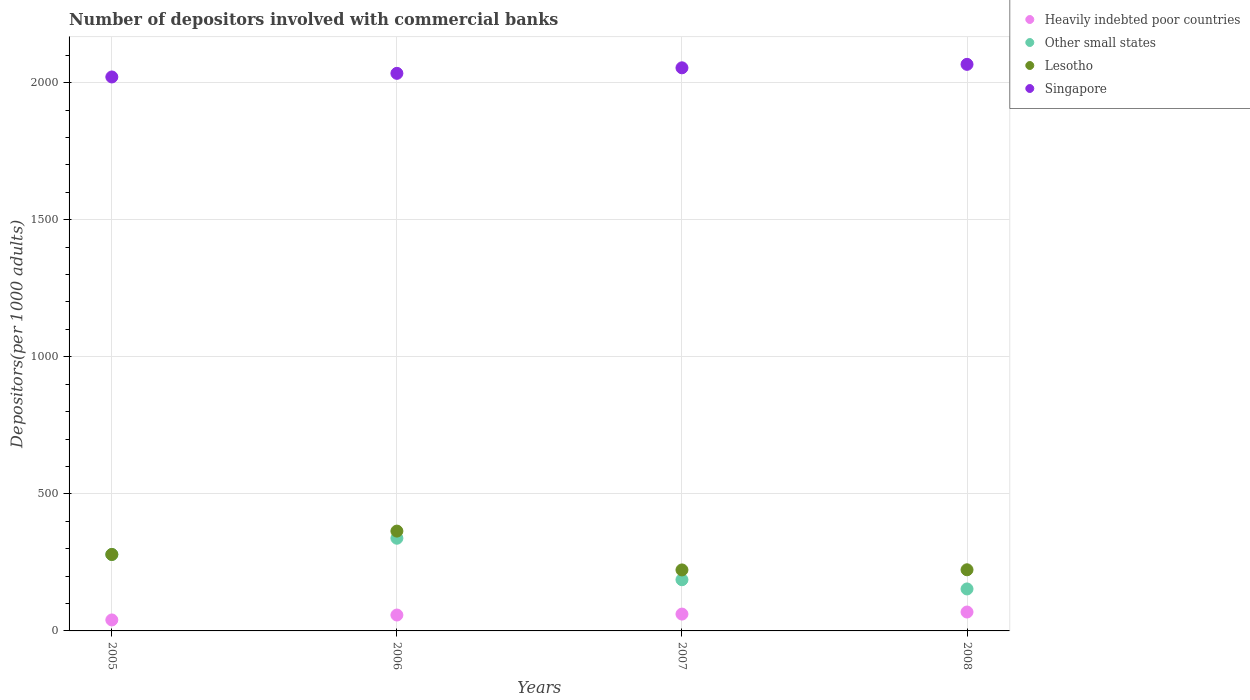What is the number of depositors involved with commercial banks in Other small states in 2005?
Keep it short and to the point. 278.86. Across all years, what is the maximum number of depositors involved with commercial banks in Other small states?
Provide a short and direct response. 338.08. Across all years, what is the minimum number of depositors involved with commercial banks in Singapore?
Offer a very short reply. 2020.56. In which year was the number of depositors involved with commercial banks in Other small states maximum?
Offer a terse response. 2006. What is the total number of depositors involved with commercial banks in Lesotho in the graph?
Your answer should be compact. 1088.47. What is the difference between the number of depositors involved with commercial banks in Heavily indebted poor countries in 2007 and that in 2008?
Offer a terse response. -7.53. What is the difference between the number of depositors involved with commercial banks in Other small states in 2008 and the number of depositors involved with commercial banks in Singapore in 2007?
Your response must be concise. -1900.84. What is the average number of depositors involved with commercial banks in Heavily indebted poor countries per year?
Keep it short and to the point. 57.09. In the year 2007, what is the difference between the number of depositors involved with commercial banks in Heavily indebted poor countries and number of depositors involved with commercial banks in Singapore?
Offer a very short reply. -1992.54. In how many years, is the number of depositors involved with commercial banks in Other small states greater than 1600?
Give a very brief answer. 0. What is the ratio of the number of depositors involved with commercial banks in Heavily indebted poor countries in 2006 to that in 2008?
Offer a very short reply. 0.84. What is the difference between the highest and the second highest number of depositors involved with commercial banks in Lesotho?
Give a very brief answer. 85.25. What is the difference between the highest and the lowest number of depositors involved with commercial banks in Heavily indebted poor countries?
Make the answer very short. 28.9. Is the sum of the number of depositors involved with commercial banks in Lesotho in 2007 and 2008 greater than the maximum number of depositors involved with commercial banks in Singapore across all years?
Provide a short and direct response. No. Does the number of depositors involved with commercial banks in Heavily indebted poor countries monotonically increase over the years?
Make the answer very short. Yes. Is the number of depositors involved with commercial banks in Singapore strictly less than the number of depositors involved with commercial banks in Other small states over the years?
Make the answer very short. No. How many dotlines are there?
Your response must be concise. 4. How many years are there in the graph?
Your response must be concise. 4. Are the values on the major ticks of Y-axis written in scientific E-notation?
Offer a very short reply. No. Does the graph contain grids?
Give a very brief answer. Yes. Where does the legend appear in the graph?
Make the answer very short. Top right. How many legend labels are there?
Provide a short and direct response. 4. What is the title of the graph?
Make the answer very short. Number of depositors involved with commercial banks. What is the label or title of the Y-axis?
Your answer should be compact. Depositors(per 1000 adults). What is the Depositors(per 1000 adults) in Heavily indebted poor countries in 2005?
Offer a very short reply. 40.04. What is the Depositors(per 1000 adults) in Other small states in 2005?
Your answer should be very brief. 278.86. What is the Depositors(per 1000 adults) of Lesotho in 2005?
Provide a succinct answer. 278.86. What is the Depositors(per 1000 adults) in Singapore in 2005?
Keep it short and to the point. 2020.56. What is the Depositors(per 1000 adults) of Heavily indebted poor countries in 2006?
Your answer should be very brief. 57.99. What is the Depositors(per 1000 adults) in Other small states in 2006?
Provide a short and direct response. 338.08. What is the Depositors(per 1000 adults) of Lesotho in 2006?
Offer a terse response. 364.12. What is the Depositors(per 1000 adults) in Singapore in 2006?
Provide a short and direct response. 2033.78. What is the Depositors(per 1000 adults) in Heavily indebted poor countries in 2007?
Your answer should be very brief. 61.41. What is the Depositors(per 1000 adults) in Other small states in 2007?
Make the answer very short. 186.74. What is the Depositors(per 1000 adults) of Lesotho in 2007?
Make the answer very short. 222.49. What is the Depositors(per 1000 adults) of Singapore in 2007?
Offer a terse response. 2053.95. What is the Depositors(per 1000 adults) in Heavily indebted poor countries in 2008?
Keep it short and to the point. 68.94. What is the Depositors(per 1000 adults) in Other small states in 2008?
Your answer should be compact. 153.11. What is the Depositors(per 1000 adults) in Lesotho in 2008?
Your response must be concise. 223. What is the Depositors(per 1000 adults) in Singapore in 2008?
Provide a succinct answer. 2066.57. Across all years, what is the maximum Depositors(per 1000 adults) in Heavily indebted poor countries?
Keep it short and to the point. 68.94. Across all years, what is the maximum Depositors(per 1000 adults) in Other small states?
Offer a very short reply. 338.08. Across all years, what is the maximum Depositors(per 1000 adults) of Lesotho?
Give a very brief answer. 364.12. Across all years, what is the maximum Depositors(per 1000 adults) in Singapore?
Keep it short and to the point. 2066.57. Across all years, what is the minimum Depositors(per 1000 adults) in Heavily indebted poor countries?
Your response must be concise. 40.04. Across all years, what is the minimum Depositors(per 1000 adults) of Other small states?
Offer a terse response. 153.11. Across all years, what is the minimum Depositors(per 1000 adults) of Lesotho?
Your response must be concise. 222.49. Across all years, what is the minimum Depositors(per 1000 adults) in Singapore?
Give a very brief answer. 2020.56. What is the total Depositors(per 1000 adults) of Heavily indebted poor countries in the graph?
Your answer should be compact. 228.38. What is the total Depositors(per 1000 adults) of Other small states in the graph?
Provide a short and direct response. 956.79. What is the total Depositors(per 1000 adults) of Lesotho in the graph?
Offer a terse response. 1088.47. What is the total Depositors(per 1000 adults) in Singapore in the graph?
Your answer should be compact. 8174.86. What is the difference between the Depositors(per 1000 adults) in Heavily indebted poor countries in 2005 and that in 2006?
Make the answer very short. -17.95. What is the difference between the Depositors(per 1000 adults) in Other small states in 2005 and that in 2006?
Make the answer very short. -59.21. What is the difference between the Depositors(per 1000 adults) in Lesotho in 2005 and that in 2006?
Make the answer very short. -85.25. What is the difference between the Depositors(per 1000 adults) in Singapore in 2005 and that in 2006?
Your response must be concise. -13.21. What is the difference between the Depositors(per 1000 adults) in Heavily indebted poor countries in 2005 and that in 2007?
Provide a succinct answer. -21.37. What is the difference between the Depositors(per 1000 adults) of Other small states in 2005 and that in 2007?
Offer a very short reply. 92.12. What is the difference between the Depositors(per 1000 adults) in Lesotho in 2005 and that in 2007?
Your answer should be very brief. 56.37. What is the difference between the Depositors(per 1000 adults) of Singapore in 2005 and that in 2007?
Your response must be concise. -33.38. What is the difference between the Depositors(per 1000 adults) in Heavily indebted poor countries in 2005 and that in 2008?
Provide a short and direct response. -28.9. What is the difference between the Depositors(per 1000 adults) in Other small states in 2005 and that in 2008?
Make the answer very short. 125.76. What is the difference between the Depositors(per 1000 adults) of Lesotho in 2005 and that in 2008?
Your answer should be compact. 55.86. What is the difference between the Depositors(per 1000 adults) in Singapore in 2005 and that in 2008?
Offer a terse response. -46.01. What is the difference between the Depositors(per 1000 adults) of Heavily indebted poor countries in 2006 and that in 2007?
Offer a very short reply. -3.42. What is the difference between the Depositors(per 1000 adults) of Other small states in 2006 and that in 2007?
Your answer should be very brief. 151.33. What is the difference between the Depositors(per 1000 adults) of Lesotho in 2006 and that in 2007?
Offer a very short reply. 141.63. What is the difference between the Depositors(per 1000 adults) of Singapore in 2006 and that in 2007?
Your response must be concise. -20.17. What is the difference between the Depositors(per 1000 adults) of Heavily indebted poor countries in 2006 and that in 2008?
Keep it short and to the point. -10.95. What is the difference between the Depositors(per 1000 adults) in Other small states in 2006 and that in 2008?
Make the answer very short. 184.97. What is the difference between the Depositors(per 1000 adults) in Lesotho in 2006 and that in 2008?
Provide a succinct answer. 141.11. What is the difference between the Depositors(per 1000 adults) in Singapore in 2006 and that in 2008?
Your answer should be compact. -32.79. What is the difference between the Depositors(per 1000 adults) in Heavily indebted poor countries in 2007 and that in 2008?
Your answer should be very brief. -7.53. What is the difference between the Depositors(per 1000 adults) in Other small states in 2007 and that in 2008?
Make the answer very short. 33.63. What is the difference between the Depositors(per 1000 adults) in Lesotho in 2007 and that in 2008?
Provide a short and direct response. -0.51. What is the difference between the Depositors(per 1000 adults) in Singapore in 2007 and that in 2008?
Offer a very short reply. -12.63. What is the difference between the Depositors(per 1000 adults) in Heavily indebted poor countries in 2005 and the Depositors(per 1000 adults) in Other small states in 2006?
Your response must be concise. -298.04. What is the difference between the Depositors(per 1000 adults) in Heavily indebted poor countries in 2005 and the Depositors(per 1000 adults) in Lesotho in 2006?
Your response must be concise. -324.08. What is the difference between the Depositors(per 1000 adults) of Heavily indebted poor countries in 2005 and the Depositors(per 1000 adults) of Singapore in 2006?
Your answer should be compact. -1993.74. What is the difference between the Depositors(per 1000 adults) of Other small states in 2005 and the Depositors(per 1000 adults) of Lesotho in 2006?
Give a very brief answer. -85.25. What is the difference between the Depositors(per 1000 adults) of Other small states in 2005 and the Depositors(per 1000 adults) of Singapore in 2006?
Offer a terse response. -1754.91. What is the difference between the Depositors(per 1000 adults) of Lesotho in 2005 and the Depositors(per 1000 adults) of Singapore in 2006?
Offer a terse response. -1754.91. What is the difference between the Depositors(per 1000 adults) of Heavily indebted poor countries in 2005 and the Depositors(per 1000 adults) of Other small states in 2007?
Give a very brief answer. -146.7. What is the difference between the Depositors(per 1000 adults) of Heavily indebted poor countries in 2005 and the Depositors(per 1000 adults) of Lesotho in 2007?
Your answer should be compact. -182.45. What is the difference between the Depositors(per 1000 adults) of Heavily indebted poor countries in 2005 and the Depositors(per 1000 adults) of Singapore in 2007?
Ensure brevity in your answer.  -2013.91. What is the difference between the Depositors(per 1000 adults) of Other small states in 2005 and the Depositors(per 1000 adults) of Lesotho in 2007?
Make the answer very short. 56.37. What is the difference between the Depositors(per 1000 adults) in Other small states in 2005 and the Depositors(per 1000 adults) in Singapore in 2007?
Ensure brevity in your answer.  -1775.08. What is the difference between the Depositors(per 1000 adults) of Lesotho in 2005 and the Depositors(per 1000 adults) of Singapore in 2007?
Your answer should be compact. -1775.08. What is the difference between the Depositors(per 1000 adults) of Heavily indebted poor countries in 2005 and the Depositors(per 1000 adults) of Other small states in 2008?
Keep it short and to the point. -113.07. What is the difference between the Depositors(per 1000 adults) in Heavily indebted poor countries in 2005 and the Depositors(per 1000 adults) in Lesotho in 2008?
Your answer should be compact. -182.96. What is the difference between the Depositors(per 1000 adults) in Heavily indebted poor countries in 2005 and the Depositors(per 1000 adults) in Singapore in 2008?
Make the answer very short. -2026.53. What is the difference between the Depositors(per 1000 adults) in Other small states in 2005 and the Depositors(per 1000 adults) in Lesotho in 2008?
Keep it short and to the point. 55.86. What is the difference between the Depositors(per 1000 adults) of Other small states in 2005 and the Depositors(per 1000 adults) of Singapore in 2008?
Your answer should be compact. -1787.71. What is the difference between the Depositors(per 1000 adults) in Lesotho in 2005 and the Depositors(per 1000 adults) in Singapore in 2008?
Ensure brevity in your answer.  -1787.71. What is the difference between the Depositors(per 1000 adults) in Heavily indebted poor countries in 2006 and the Depositors(per 1000 adults) in Other small states in 2007?
Provide a succinct answer. -128.75. What is the difference between the Depositors(per 1000 adults) of Heavily indebted poor countries in 2006 and the Depositors(per 1000 adults) of Lesotho in 2007?
Offer a very short reply. -164.5. What is the difference between the Depositors(per 1000 adults) in Heavily indebted poor countries in 2006 and the Depositors(per 1000 adults) in Singapore in 2007?
Provide a succinct answer. -1995.96. What is the difference between the Depositors(per 1000 adults) in Other small states in 2006 and the Depositors(per 1000 adults) in Lesotho in 2007?
Provide a short and direct response. 115.58. What is the difference between the Depositors(per 1000 adults) of Other small states in 2006 and the Depositors(per 1000 adults) of Singapore in 2007?
Keep it short and to the point. -1715.87. What is the difference between the Depositors(per 1000 adults) of Lesotho in 2006 and the Depositors(per 1000 adults) of Singapore in 2007?
Ensure brevity in your answer.  -1689.83. What is the difference between the Depositors(per 1000 adults) of Heavily indebted poor countries in 2006 and the Depositors(per 1000 adults) of Other small states in 2008?
Offer a terse response. -95.12. What is the difference between the Depositors(per 1000 adults) of Heavily indebted poor countries in 2006 and the Depositors(per 1000 adults) of Lesotho in 2008?
Offer a terse response. -165.01. What is the difference between the Depositors(per 1000 adults) of Heavily indebted poor countries in 2006 and the Depositors(per 1000 adults) of Singapore in 2008?
Provide a short and direct response. -2008.58. What is the difference between the Depositors(per 1000 adults) in Other small states in 2006 and the Depositors(per 1000 adults) in Lesotho in 2008?
Your answer should be very brief. 115.07. What is the difference between the Depositors(per 1000 adults) of Other small states in 2006 and the Depositors(per 1000 adults) of Singapore in 2008?
Give a very brief answer. -1728.5. What is the difference between the Depositors(per 1000 adults) of Lesotho in 2006 and the Depositors(per 1000 adults) of Singapore in 2008?
Provide a short and direct response. -1702.46. What is the difference between the Depositors(per 1000 adults) of Heavily indebted poor countries in 2007 and the Depositors(per 1000 adults) of Other small states in 2008?
Your answer should be compact. -91.7. What is the difference between the Depositors(per 1000 adults) of Heavily indebted poor countries in 2007 and the Depositors(per 1000 adults) of Lesotho in 2008?
Your answer should be very brief. -161.6. What is the difference between the Depositors(per 1000 adults) in Heavily indebted poor countries in 2007 and the Depositors(per 1000 adults) in Singapore in 2008?
Provide a succinct answer. -2005.16. What is the difference between the Depositors(per 1000 adults) of Other small states in 2007 and the Depositors(per 1000 adults) of Lesotho in 2008?
Make the answer very short. -36.26. What is the difference between the Depositors(per 1000 adults) of Other small states in 2007 and the Depositors(per 1000 adults) of Singapore in 2008?
Provide a succinct answer. -1879.83. What is the difference between the Depositors(per 1000 adults) in Lesotho in 2007 and the Depositors(per 1000 adults) in Singapore in 2008?
Provide a short and direct response. -1844.08. What is the average Depositors(per 1000 adults) in Heavily indebted poor countries per year?
Provide a succinct answer. 57.09. What is the average Depositors(per 1000 adults) in Other small states per year?
Give a very brief answer. 239.2. What is the average Depositors(per 1000 adults) in Lesotho per year?
Give a very brief answer. 272.12. What is the average Depositors(per 1000 adults) of Singapore per year?
Make the answer very short. 2043.72. In the year 2005, what is the difference between the Depositors(per 1000 adults) of Heavily indebted poor countries and Depositors(per 1000 adults) of Other small states?
Your response must be concise. -238.82. In the year 2005, what is the difference between the Depositors(per 1000 adults) of Heavily indebted poor countries and Depositors(per 1000 adults) of Lesotho?
Offer a terse response. -238.82. In the year 2005, what is the difference between the Depositors(per 1000 adults) of Heavily indebted poor countries and Depositors(per 1000 adults) of Singapore?
Provide a short and direct response. -1980.52. In the year 2005, what is the difference between the Depositors(per 1000 adults) in Other small states and Depositors(per 1000 adults) in Lesotho?
Your answer should be compact. 0. In the year 2005, what is the difference between the Depositors(per 1000 adults) of Other small states and Depositors(per 1000 adults) of Singapore?
Give a very brief answer. -1741.7. In the year 2005, what is the difference between the Depositors(per 1000 adults) of Lesotho and Depositors(per 1000 adults) of Singapore?
Ensure brevity in your answer.  -1741.7. In the year 2006, what is the difference between the Depositors(per 1000 adults) in Heavily indebted poor countries and Depositors(per 1000 adults) in Other small states?
Your response must be concise. -280.08. In the year 2006, what is the difference between the Depositors(per 1000 adults) in Heavily indebted poor countries and Depositors(per 1000 adults) in Lesotho?
Provide a short and direct response. -306.13. In the year 2006, what is the difference between the Depositors(per 1000 adults) in Heavily indebted poor countries and Depositors(per 1000 adults) in Singapore?
Give a very brief answer. -1975.79. In the year 2006, what is the difference between the Depositors(per 1000 adults) of Other small states and Depositors(per 1000 adults) of Lesotho?
Provide a succinct answer. -26.04. In the year 2006, what is the difference between the Depositors(per 1000 adults) in Other small states and Depositors(per 1000 adults) in Singapore?
Your response must be concise. -1695.7. In the year 2006, what is the difference between the Depositors(per 1000 adults) in Lesotho and Depositors(per 1000 adults) in Singapore?
Your response must be concise. -1669.66. In the year 2007, what is the difference between the Depositors(per 1000 adults) of Heavily indebted poor countries and Depositors(per 1000 adults) of Other small states?
Offer a terse response. -125.33. In the year 2007, what is the difference between the Depositors(per 1000 adults) of Heavily indebted poor countries and Depositors(per 1000 adults) of Lesotho?
Your answer should be very brief. -161.08. In the year 2007, what is the difference between the Depositors(per 1000 adults) in Heavily indebted poor countries and Depositors(per 1000 adults) in Singapore?
Ensure brevity in your answer.  -1992.54. In the year 2007, what is the difference between the Depositors(per 1000 adults) of Other small states and Depositors(per 1000 adults) of Lesotho?
Keep it short and to the point. -35.75. In the year 2007, what is the difference between the Depositors(per 1000 adults) in Other small states and Depositors(per 1000 adults) in Singapore?
Your response must be concise. -1867.21. In the year 2007, what is the difference between the Depositors(per 1000 adults) of Lesotho and Depositors(per 1000 adults) of Singapore?
Provide a short and direct response. -1831.46. In the year 2008, what is the difference between the Depositors(per 1000 adults) of Heavily indebted poor countries and Depositors(per 1000 adults) of Other small states?
Your answer should be compact. -84.17. In the year 2008, what is the difference between the Depositors(per 1000 adults) in Heavily indebted poor countries and Depositors(per 1000 adults) in Lesotho?
Make the answer very short. -154.06. In the year 2008, what is the difference between the Depositors(per 1000 adults) of Heavily indebted poor countries and Depositors(per 1000 adults) of Singapore?
Your answer should be very brief. -1997.63. In the year 2008, what is the difference between the Depositors(per 1000 adults) in Other small states and Depositors(per 1000 adults) in Lesotho?
Ensure brevity in your answer.  -69.9. In the year 2008, what is the difference between the Depositors(per 1000 adults) in Other small states and Depositors(per 1000 adults) in Singapore?
Your response must be concise. -1913.47. In the year 2008, what is the difference between the Depositors(per 1000 adults) of Lesotho and Depositors(per 1000 adults) of Singapore?
Provide a short and direct response. -1843.57. What is the ratio of the Depositors(per 1000 adults) in Heavily indebted poor countries in 2005 to that in 2006?
Offer a terse response. 0.69. What is the ratio of the Depositors(per 1000 adults) of Other small states in 2005 to that in 2006?
Ensure brevity in your answer.  0.82. What is the ratio of the Depositors(per 1000 adults) in Lesotho in 2005 to that in 2006?
Make the answer very short. 0.77. What is the ratio of the Depositors(per 1000 adults) of Singapore in 2005 to that in 2006?
Offer a very short reply. 0.99. What is the ratio of the Depositors(per 1000 adults) of Heavily indebted poor countries in 2005 to that in 2007?
Your answer should be very brief. 0.65. What is the ratio of the Depositors(per 1000 adults) in Other small states in 2005 to that in 2007?
Offer a terse response. 1.49. What is the ratio of the Depositors(per 1000 adults) of Lesotho in 2005 to that in 2007?
Keep it short and to the point. 1.25. What is the ratio of the Depositors(per 1000 adults) in Singapore in 2005 to that in 2007?
Provide a succinct answer. 0.98. What is the ratio of the Depositors(per 1000 adults) of Heavily indebted poor countries in 2005 to that in 2008?
Your response must be concise. 0.58. What is the ratio of the Depositors(per 1000 adults) of Other small states in 2005 to that in 2008?
Offer a terse response. 1.82. What is the ratio of the Depositors(per 1000 adults) in Lesotho in 2005 to that in 2008?
Make the answer very short. 1.25. What is the ratio of the Depositors(per 1000 adults) in Singapore in 2005 to that in 2008?
Ensure brevity in your answer.  0.98. What is the ratio of the Depositors(per 1000 adults) in Heavily indebted poor countries in 2006 to that in 2007?
Make the answer very short. 0.94. What is the ratio of the Depositors(per 1000 adults) in Other small states in 2006 to that in 2007?
Ensure brevity in your answer.  1.81. What is the ratio of the Depositors(per 1000 adults) in Lesotho in 2006 to that in 2007?
Offer a very short reply. 1.64. What is the ratio of the Depositors(per 1000 adults) of Singapore in 2006 to that in 2007?
Provide a short and direct response. 0.99. What is the ratio of the Depositors(per 1000 adults) in Heavily indebted poor countries in 2006 to that in 2008?
Ensure brevity in your answer.  0.84. What is the ratio of the Depositors(per 1000 adults) in Other small states in 2006 to that in 2008?
Ensure brevity in your answer.  2.21. What is the ratio of the Depositors(per 1000 adults) in Lesotho in 2006 to that in 2008?
Make the answer very short. 1.63. What is the ratio of the Depositors(per 1000 adults) in Singapore in 2006 to that in 2008?
Ensure brevity in your answer.  0.98. What is the ratio of the Depositors(per 1000 adults) of Heavily indebted poor countries in 2007 to that in 2008?
Your answer should be very brief. 0.89. What is the ratio of the Depositors(per 1000 adults) of Other small states in 2007 to that in 2008?
Give a very brief answer. 1.22. What is the ratio of the Depositors(per 1000 adults) of Lesotho in 2007 to that in 2008?
Give a very brief answer. 1. What is the ratio of the Depositors(per 1000 adults) in Singapore in 2007 to that in 2008?
Your response must be concise. 0.99. What is the difference between the highest and the second highest Depositors(per 1000 adults) of Heavily indebted poor countries?
Ensure brevity in your answer.  7.53. What is the difference between the highest and the second highest Depositors(per 1000 adults) of Other small states?
Provide a succinct answer. 59.21. What is the difference between the highest and the second highest Depositors(per 1000 adults) in Lesotho?
Give a very brief answer. 85.25. What is the difference between the highest and the second highest Depositors(per 1000 adults) in Singapore?
Keep it short and to the point. 12.63. What is the difference between the highest and the lowest Depositors(per 1000 adults) of Heavily indebted poor countries?
Make the answer very short. 28.9. What is the difference between the highest and the lowest Depositors(per 1000 adults) in Other small states?
Offer a very short reply. 184.97. What is the difference between the highest and the lowest Depositors(per 1000 adults) in Lesotho?
Keep it short and to the point. 141.63. What is the difference between the highest and the lowest Depositors(per 1000 adults) of Singapore?
Give a very brief answer. 46.01. 